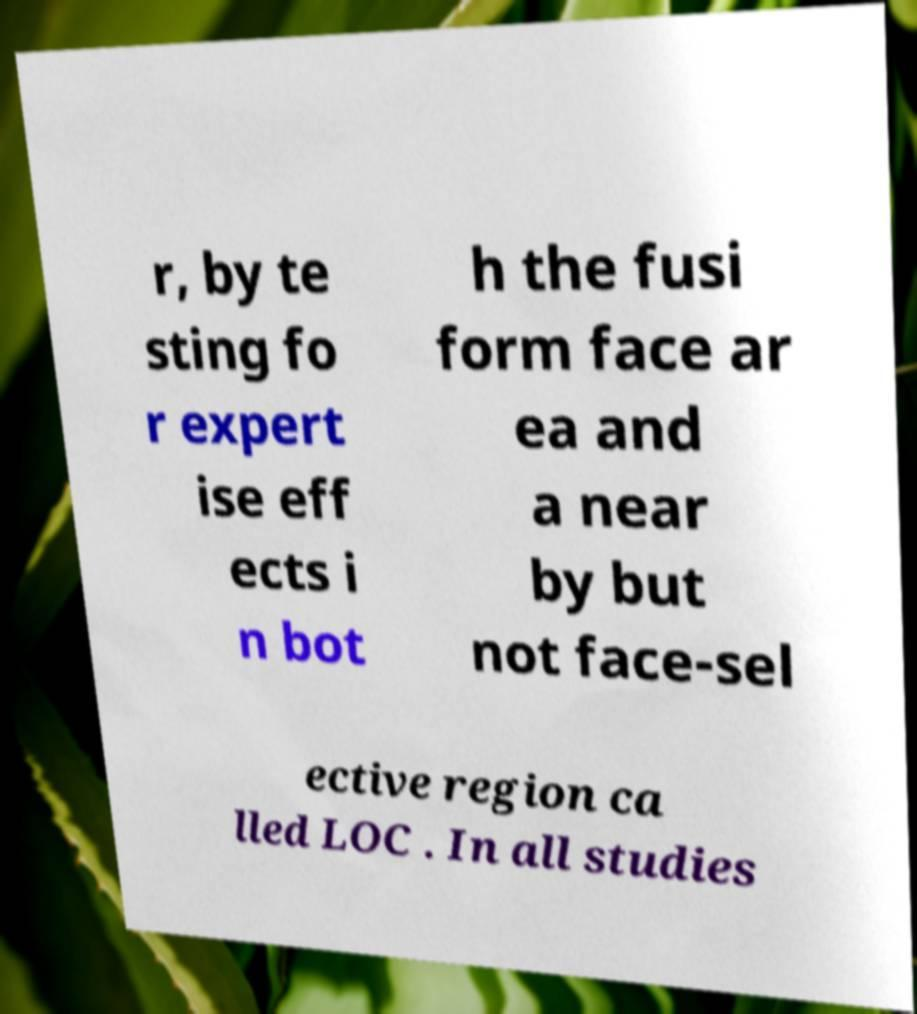Please identify and transcribe the text found in this image. r, by te sting fo r expert ise eff ects i n bot h the fusi form face ar ea and a near by but not face-sel ective region ca lled LOC . In all studies 